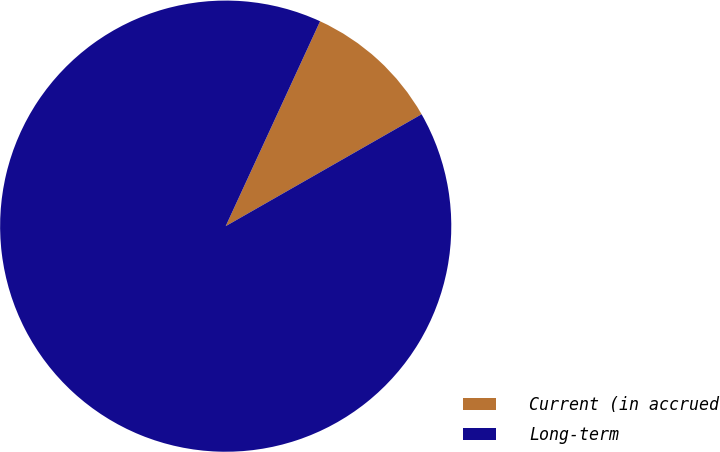<chart> <loc_0><loc_0><loc_500><loc_500><pie_chart><fcel>Current (in accrued<fcel>Long-term<nl><fcel>9.87%<fcel>90.13%<nl></chart> 